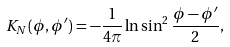Convert formula to latex. <formula><loc_0><loc_0><loc_500><loc_500>K _ { N } ( \phi , \phi ^ { \prime } ) = - \frac { 1 } { 4 \pi } \ln \sin ^ { 2 } \frac { \phi - \phi ^ { \prime } } { 2 } ,</formula> 